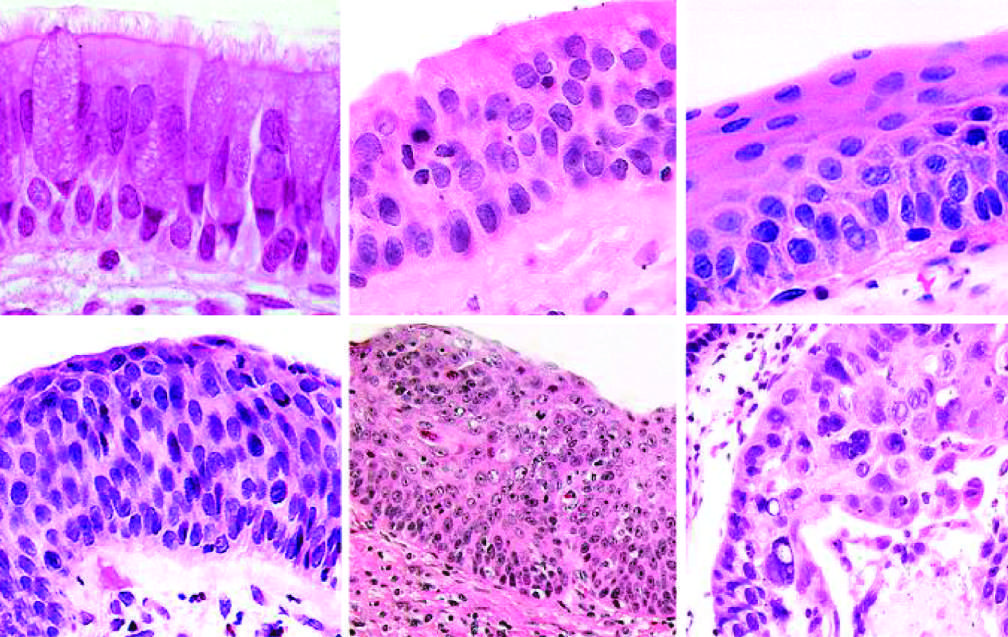re the cytologic features of cis similar to those in frank carcinoma apart from the lack of basement membrane disruption in cis?
Answer the question using a single word or phrase. Yes 